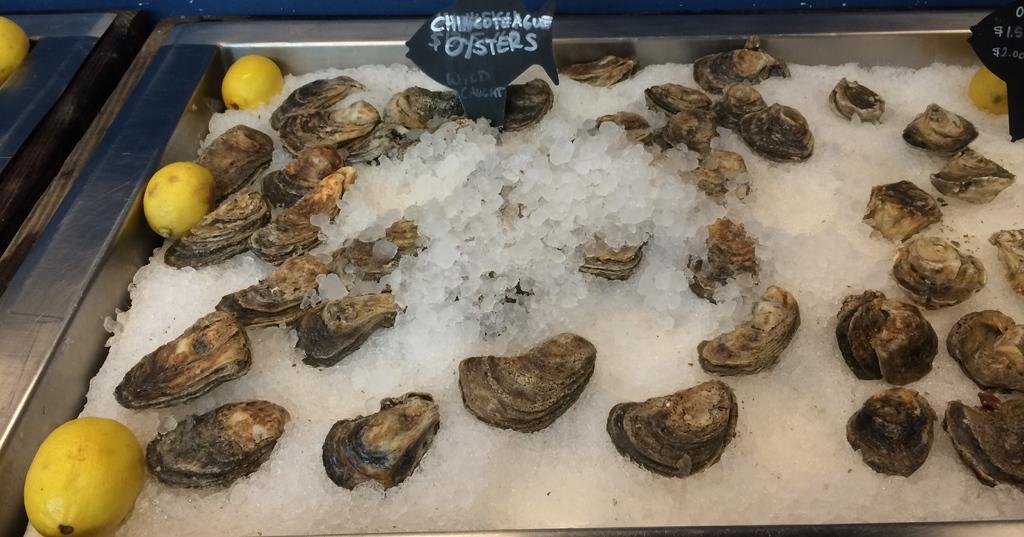Please provide a concise description of this image. In this image, we can see some sea shells with salt in the steel container. In this image, we can see few lemons. Top of the image, there are two name boards we can see. 